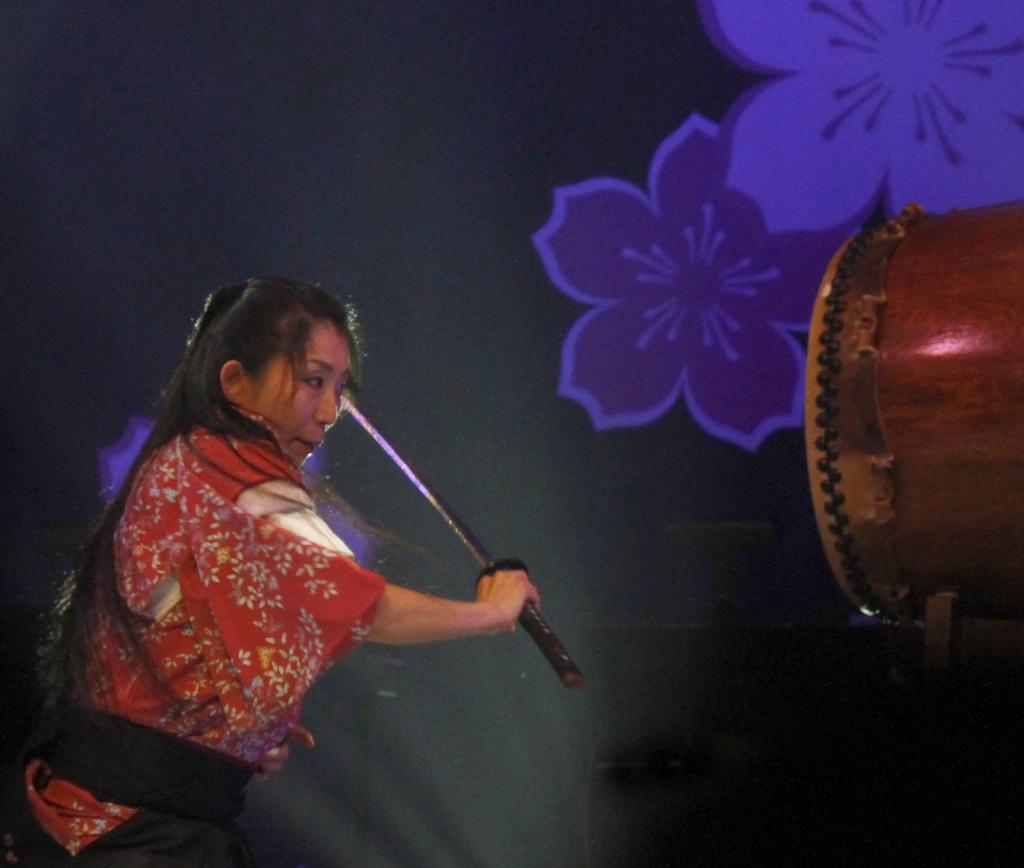Who is the main subject in the image? There is a woman in the image. What is the woman wearing? The woman is wearing a red dress. What is the woman holding in the image? The woman is holding a stick. What is the woman doing with the stick? The woman is playing drums with the stick. What can be seen in the background of the image? There is a flowers painting in the background. What type of veil is the woman wearing in the image? There is no veil present in the image; the woman is wearing a red dress. How many pies can be seen in the image? There are no pies present in the image. 